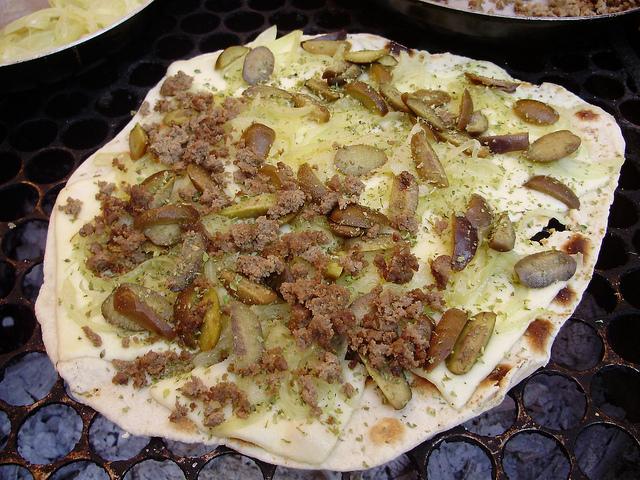Are there mushrooms?
Write a very short answer. Yes. Is there any sausage on the pizza?
Quick response, please. Yes. Is there meat?
Keep it brief. Yes. What is the pizza on?
Write a very short answer. Table. Is this a pizza?
Concise answer only. Yes. 